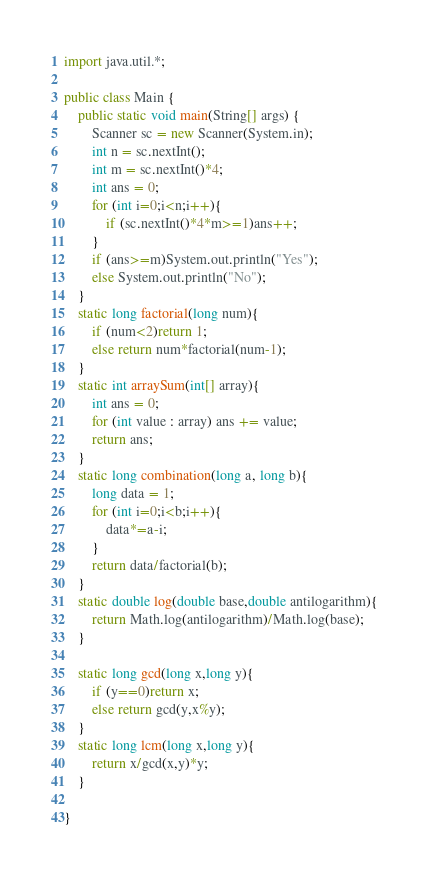Convert code to text. <code><loc_0><loc_0><loc_500><loc_500><_Java_>import java.util.*;

public class Main {
    public static void main(String[] args) {
        Scanner sc = new Scanner(System.in);
        int n = sc.nextInt();
        int m = sc.nextInt()*4;
        int ans = 0;
        for (int i=0;i<n;i++){
            if (sc.nextInt()*4*m>=1)ans++;
        }
        if (ans>=m)System.out.println("Yes");
        else System.out.println("No");
    }
    static long factorial(long num){
        if (num<2)return 1;
        else return num*factorial(num-1);
    }
    static int arraySum(int[] array){
        int ans = 0;
        for (int value : array) ans += value;
        return ans;
    }
    static long combination(long a, long b){
        long data = 1;
        for (int i=0;i<b;i++){
            data*=a-i;
        }
        return data/factorial(b);
    }
    static double log(double base,double antilogarithm){
        return Math.log(antilogarithm)/Math.log(base);
    }

    static long gcd(long x,long y){
        if (y==0)return x;
        else return gcd(y,x%y);
    }
    static long lcm(long x,long y){
        return x/gcd(x,y)*y;
    }

}
</code> 